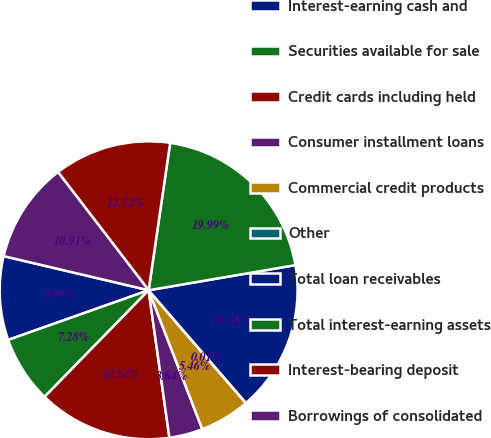Convert chart. <chart><loc_0><loc_0><loc_500><loc_500><pie_chart><fcel>Interest-earning cash and<fcel>Securities available for sale<fcel>Credit cards including held<fcel>Consumer installment loans<fcel>Commercial credit products<fcel>Other<fcel>Total loan receivables<fcel>Total interest-earning assets<fcel>Interest-bearing deposit<fcel>Borrowings of consolidated<nl><fcel>9.09%<fcel>7.28%<fcel>14.54%<fcel>3.64%<fcel>5.46%<fcel>0.01%<fcel>16.36%<fcel>19.99%<fcel>12.72%<fcel>10.91%<nl></chart> 